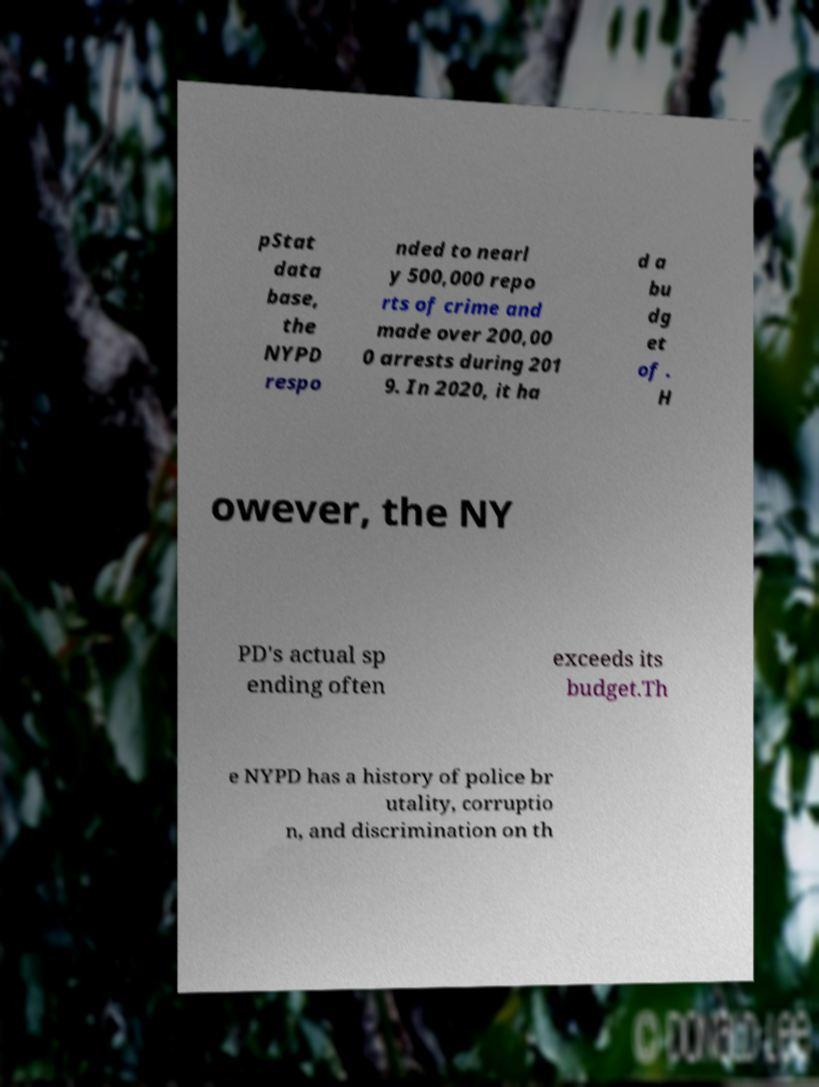There's text embedded in this image that I need extracted. Can you transcribe it verbatim? pStat data base, the NYPD respo nded to nearl y 500,000 repo rts of crime and made over 200,00 0 arrests during 201 9. In 2020, it ha d a bu dg et of . H owever, the NY PD's actual sp ending often exceeds its budget.Th e NYPD has a history of police br utality, corruptio n, and discrimination on th 